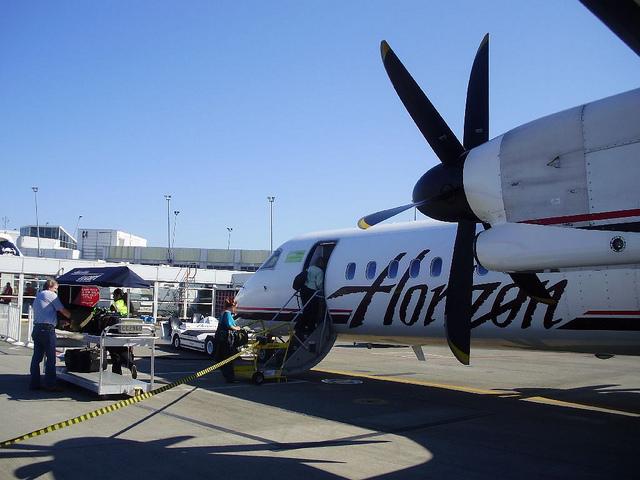What is the name on the airplane?
Be succinct. Horizon. Is it cloudy?
Answer briefly. No. What airline is this?
Be succinct. Horizon. Is anyone on the ladder?
Answer briefly. Yes. How many people are in the scene?
Concise answer only. 4. How many blades does the propeller have?
Short answer required. 6. Are people leaving or approaching the plane?
Answer briefly. Approaching. What furniture is under the plane?
Give a very brief answer. Stairs. How many propellers are there?
Keep it brief. 1. How many stripes on each blade of the propeller?
Short answer required. 1. What kind of plane is this?
Give a very brief answer. Jet. 